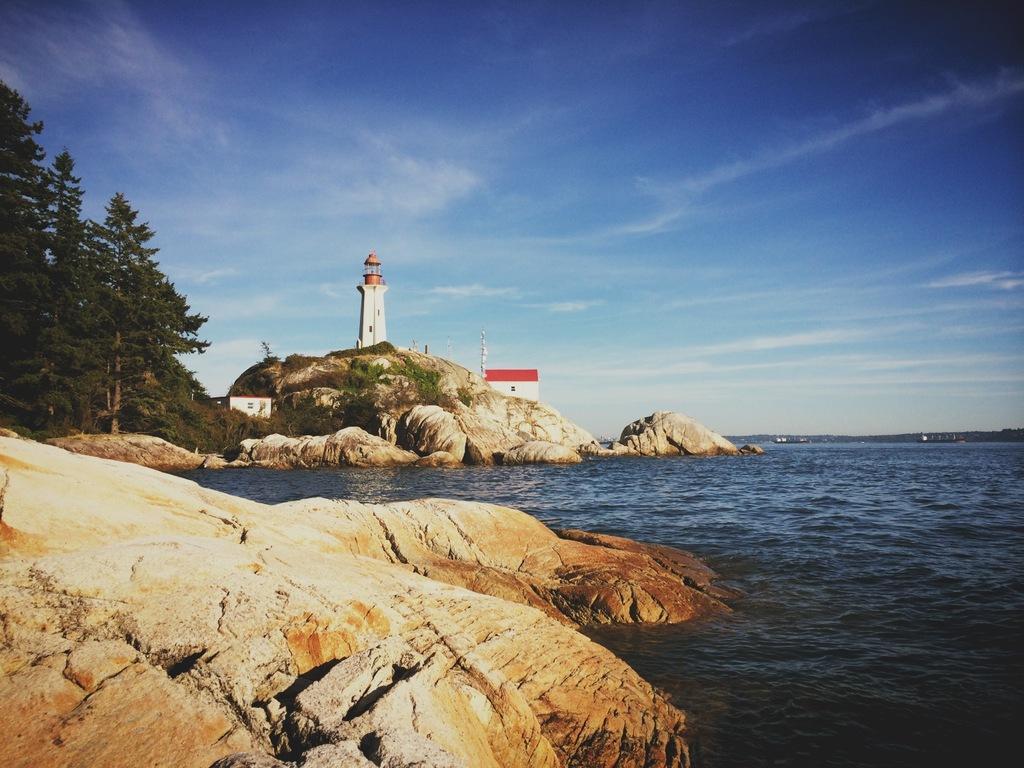Describe this image in one or two sentences. In this image at the bottom there is a river and some rocks, and in the background there are some rocks, trees, tower, flag and some poles. At the top there is sky. 